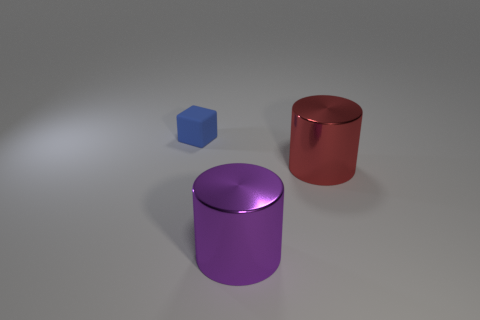Add 2 cyan cylinders. How many objects exist? 5 Subtract all cubes. How many objects are left? 2 Add 1 purple cylinders. How many purple cylinders exist? 2 Subtract 0 yellow cylinders. How many objects are left? 3 Subtract all big red objects. Subtract all big shiny spheres. How many objects are left? 2 Add 3 big red metal objects. How many big red metal objects are left? 4 